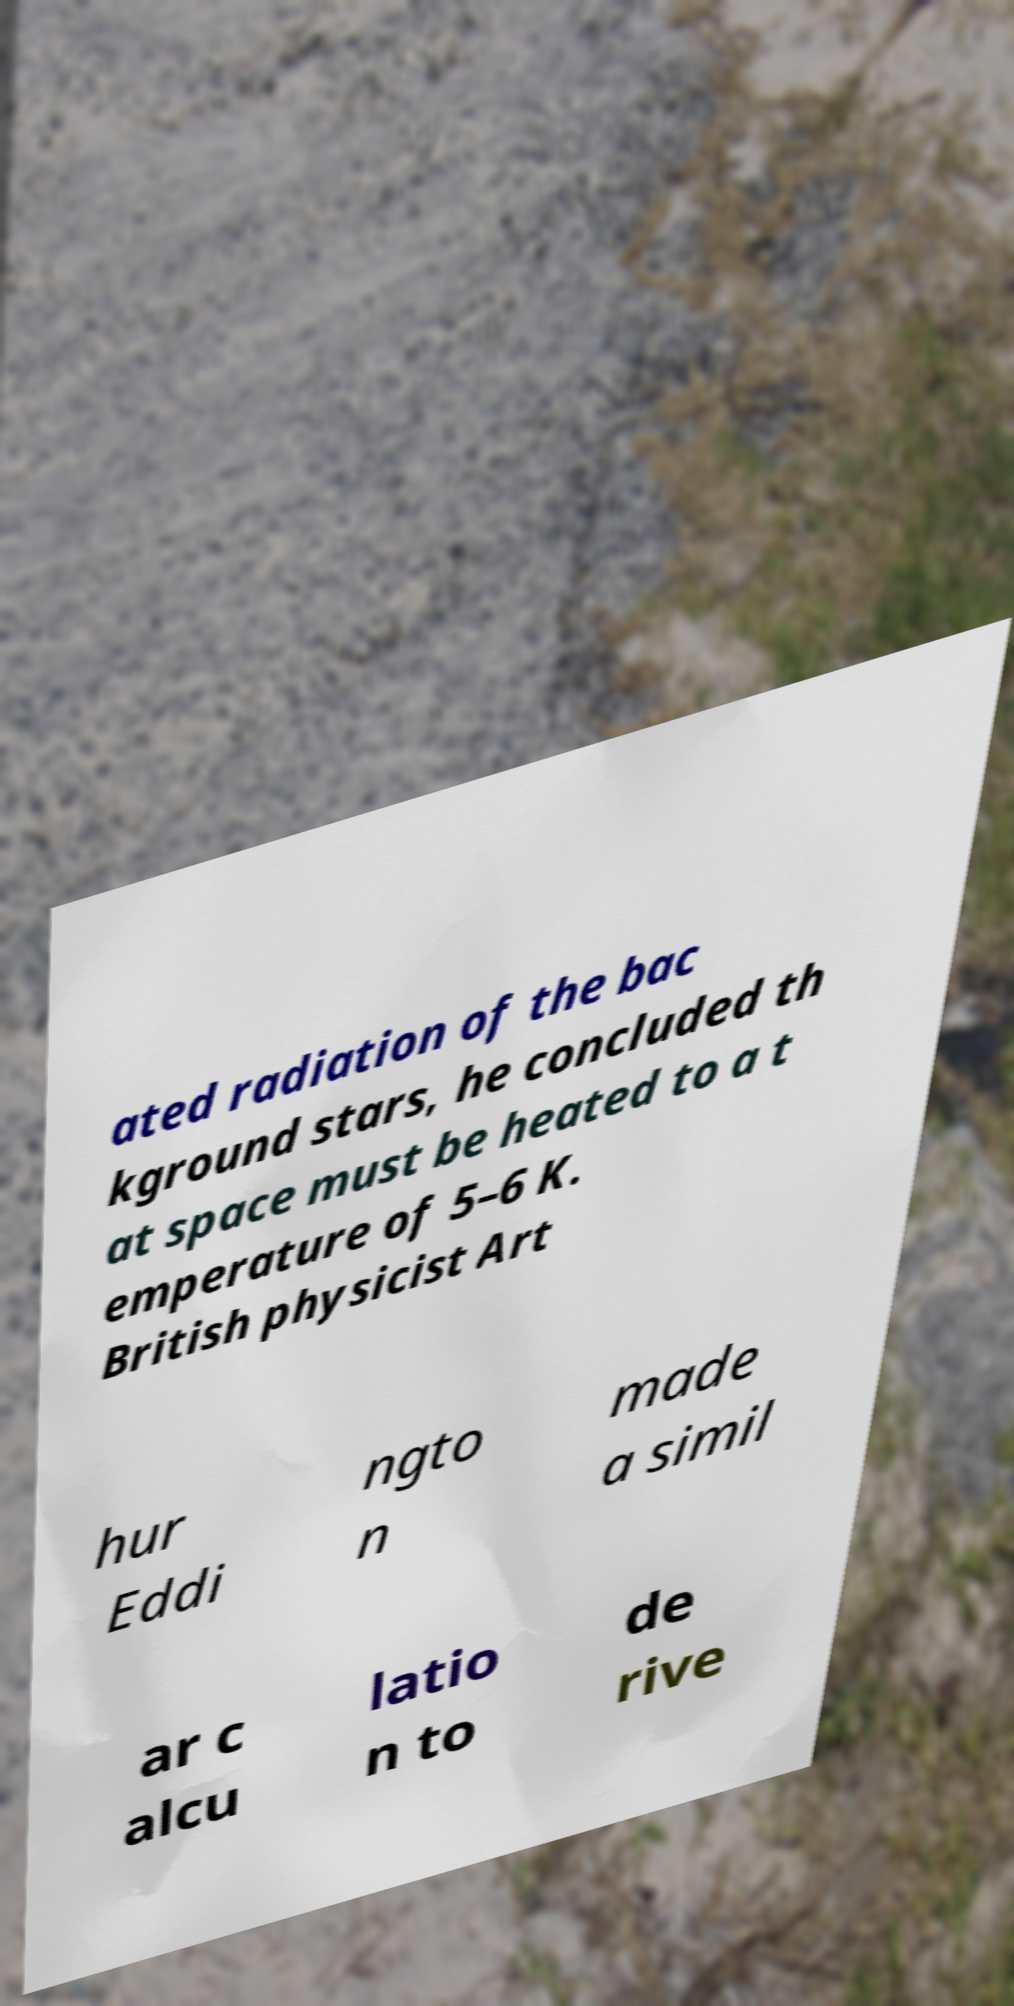Can you accurately transcribe the text from the provided image for me? ated radiation of the bac kground stars, he concluded th at space must be heated to a t emperature of 5–6 K. British physicist Art hur Eddi ngto n made a simil ar c alcu latio n to de rive 